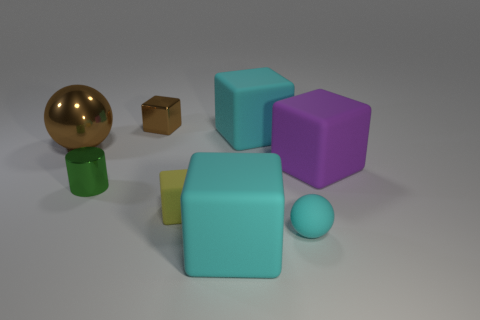How big is the brown shiny object that is on the left side of the brown metal object on the right side of the tiny green object?
Your response must be concise. Large. How many tiny things are either purple cubes or cyan metal cylinders?
Ensure brevity in your answer.  0. Are there fewer cyan balls than tiny objects?
Your answer should be compact. Yes. Is there anything else that has the same size as the brown shiny sphere?
Make the answer very short. Yes. Is the rubber sphere the same color as the metallic block?
Offer a very short reply. No. Is the number of big brown balls greater than the number of large yellow objects?
Your answer should be compact. Yes. What number of other things are the same color as the small metallic cube?
Offer a terse response. 1. What number of big cyan cubes are left of the large cyan matte block that is behind the tiny cyan matte sphere?
Provide a short and direct response. 1. There is a purple thing; are there any small cubes on the right side of it?
Offer a very short reply. No. There is a large object that is to the left of the small metal object that is behind the tiny green metal cylinder; what is its shape?
Make the answer very short. Sphere. 